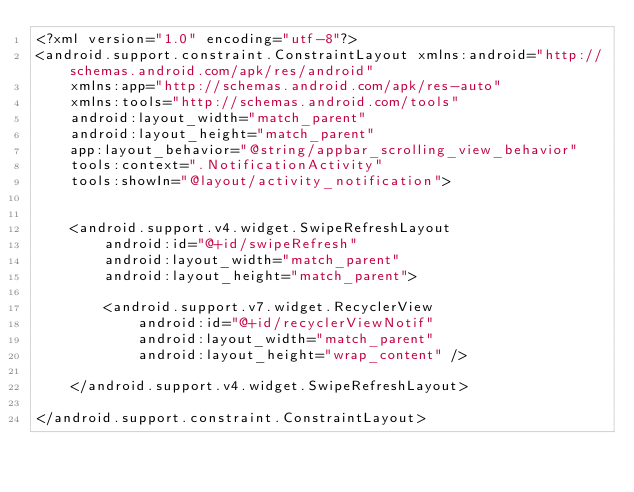Convert code to text. <code><loc_0><loc_0><loc_500><loc_500><_XML_><?xml version="1.0" encoding="utf-8"?>
<android.support.constraint.ConstraintLayout xmlns:android="http://schemas.android.com/apk/res/android"
    xmlns:app="http://schemas.android.com/apk/res-auto"
    xmlns:tools="http://schemas.android.com/tools"
    android:layout_width="match_parent"
    android:layout_height="match_parent"
    app:layout_behavior="@string/appbar_scrolling_view_behavior"
    tools:context=".NotificationActivity"
    tools:showIn="@layout/activity_notification">


    <android.support.v4.widget.SwipeRefreshLayout
        android:id="@+id/swipeRefresh"
        android:layout_width="match_parent"
        android:layout_height="match_parent">

        <android.support.v7.widget.RecyclerView
            android:id="@+id/recyclerViewNotif"
            android:layout_width="match_parent"
            android:layout_height="wrap_content" />

    </android.support.v4.widget.SwipeRefreshLayout>

</android.support.constraint.ConstraintLayout>
</code> 